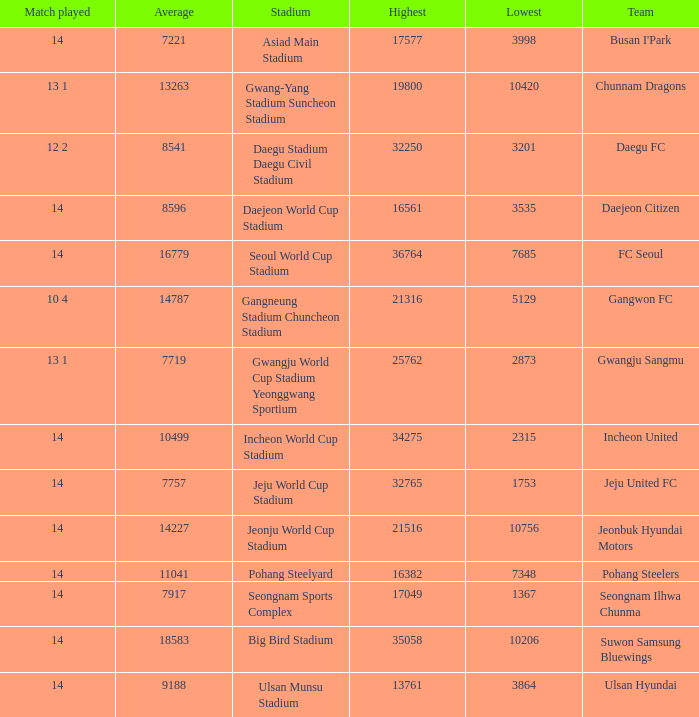Which team has a match played of 10 4? Gangwon FC. 